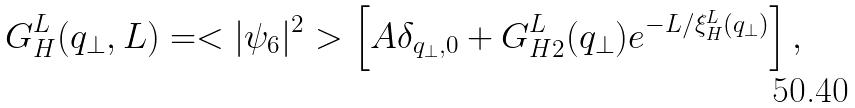Convert formula to latex. <formula><loc_0><loc_0><loc_500><loc_500>G _ { H } ^ { L } ( { q _ { \perp } } , L ) = < | \psi _ { 6 } | ^ { 2 } > \left [ A \delta _ { { { q } _ { \perp } } , { 0 } } + G ^ { L } _ { H 2 } ( { q _ { \perp } } ) e ^ { - L / \xi _ { H } ^ { L } ( { q _ { \perp } } ) } \right ] ,</formula> 